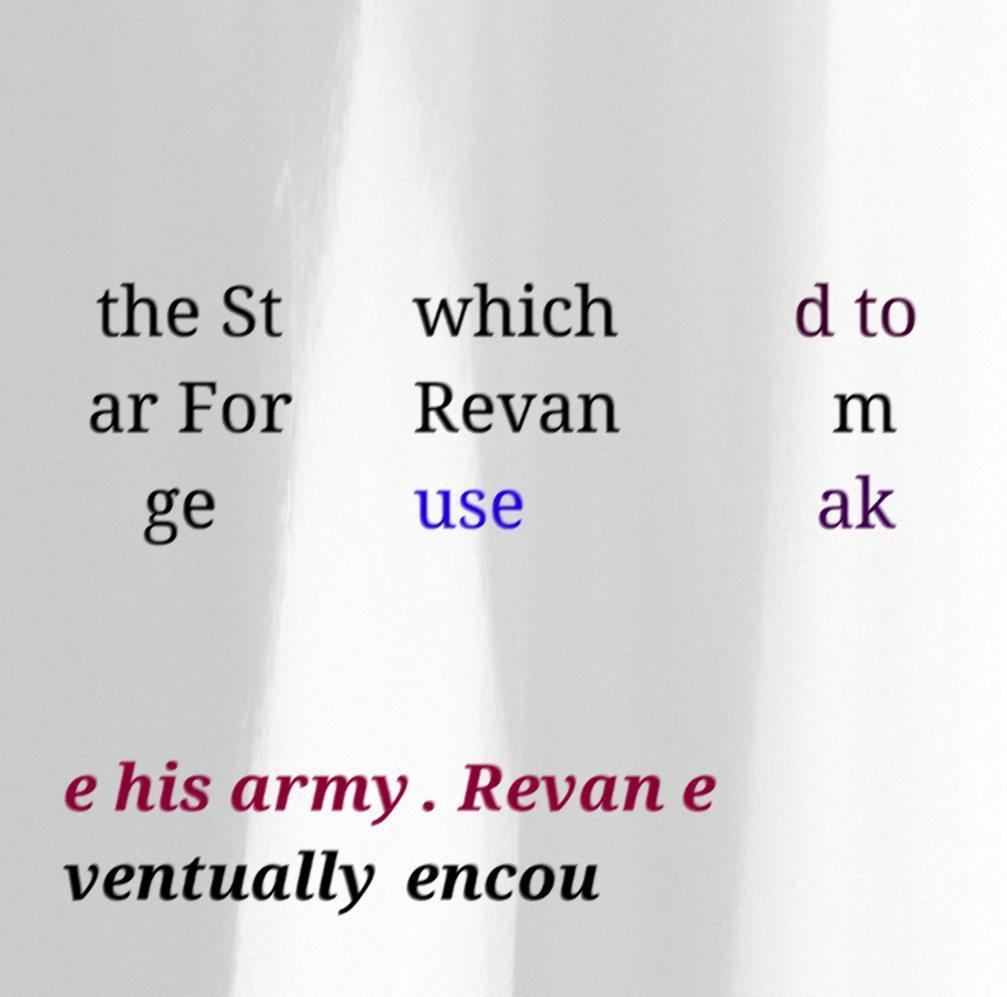I need the written content from this picture converted into text. Can you do that? the St ar For ge which Revan use d to m ak e his army. Revan e ventually encou 